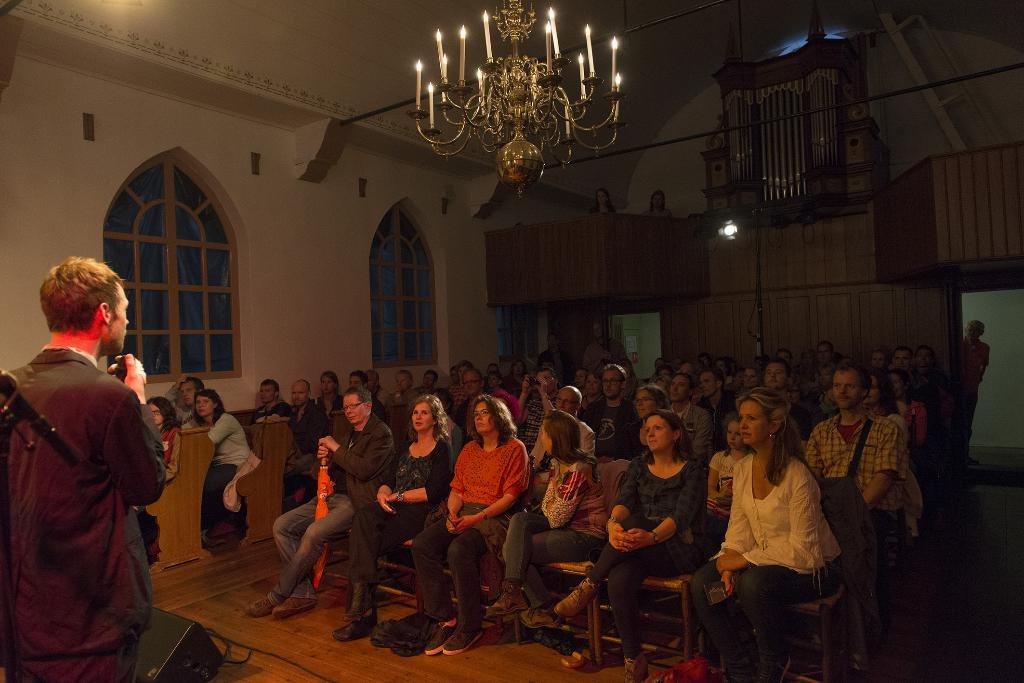What are the people in the image doing? The people in the image are sitting on chairs. What can be seen through the windows in the image? Windows are visible in the image, but we cannot see through them based on the provided facts. What type of lighting fixture is present in the image? A chandelier is present in the image. What type of modern technology can be seen in the image? Electronic gadgets are visible in the image. Can you describe any other objects in the image? There are other objects in the image, but their specific details are not mentioned in the provided facts. Where is the shelf located in the image? There is no shelf present in the image. What type of rifle can be seen in the hands of the people in the image? There are no rifles present in the image; the people are sitting on chairs. 